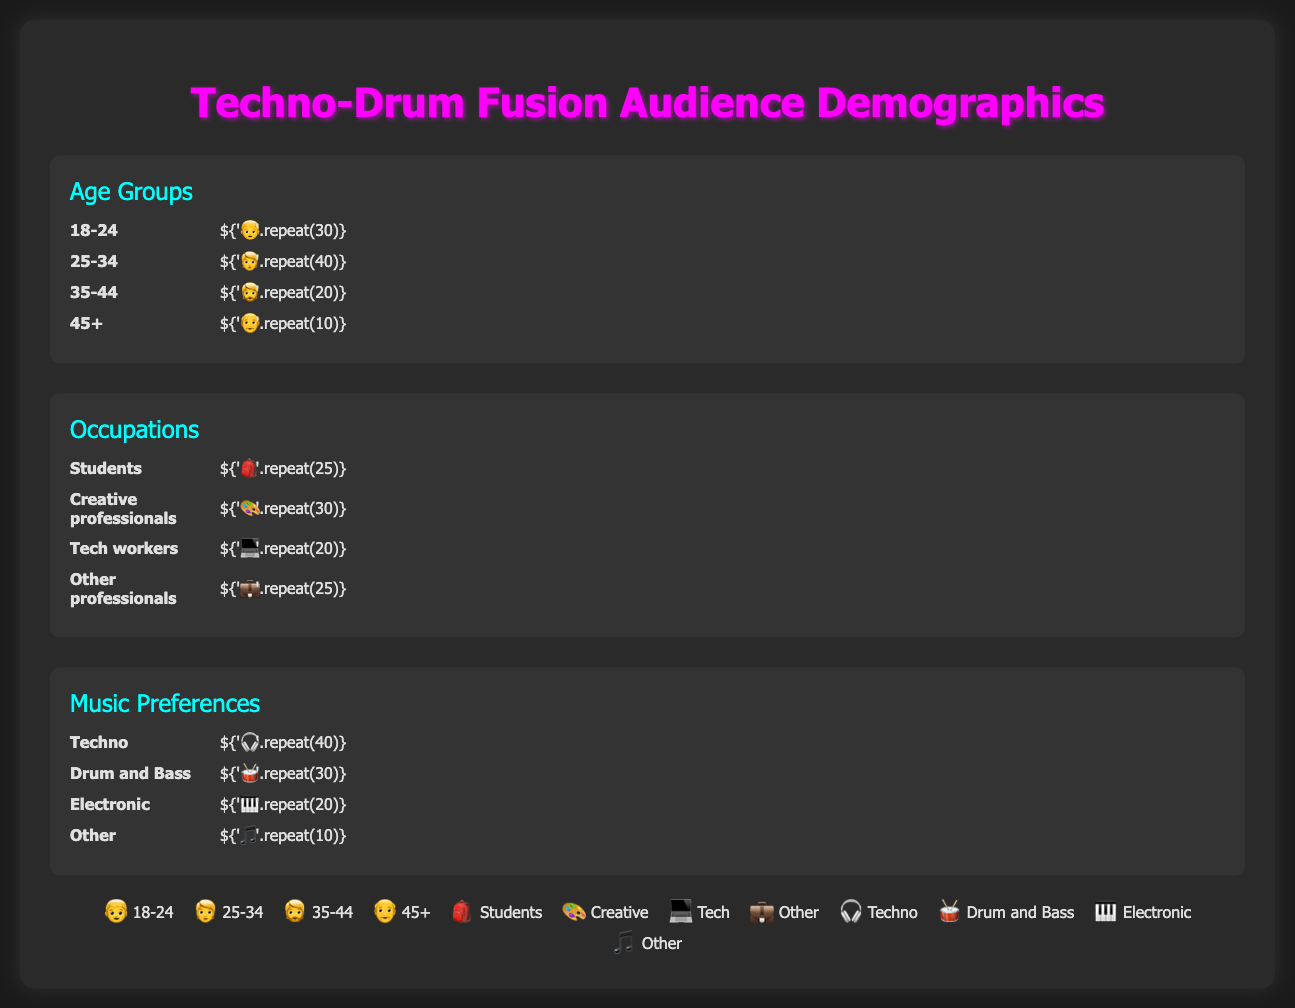Who represents the largest age group in the audience? From the Isotype Plot, the 25-34 age group has 40 icons, which is the highest compared to other age groups (each icon represents 10 attendees).
Answer: 25-34 How many more 18-24-year-olds are there compared to 35-44-year-olds? The 18-24 age group has 30 icons and the 35-44 age group has 20 icons. Subtracting the two gives 30 - 20 = 10 icons. Each icon represents 10 attendees, so the difference is 10 * 10 = 100 attendees.
Answer: 100 What fraction of the attendees are identified as "Other professionals"? The "Other professionals" group has 25 icons. Since there are 100 icons in total representing 1000 attendees, the fraction is 25/100 = 1/4.
Answer: 1/4 Which music genre is preferred by the least number of attendees? The genre "Other" has the least number of icons, totaling 10 icons. This translates to 100 attendees, which is fewer than any other genre presented.
Answer: Other Are there more tech workers or students in the audience? The plot shows 20 icons for "Tech workers" and 25 icons for "Students". This translates to 200 tech workers and 250 students. Since 250 is greater than 200, there are more students.
Answer: Students What is the total number of attendees who prefer either Techno or Drum and Bass genres? The Techno genre has 40 icons and the Drum and Bass genre has 30 icons. Combined, they add up to 40 + 30 = 70 icons. Each icon represents 10 attendees, so it totals 70 * 10 = 700 attendees.
Answer: 700 What is the difference in the number of attendees between the "Creative professionals" and "Other professionals"? "Creative professionals" have 30 icons and "Other professionals" have 25 icons. The difference is 30 - 25 = 5 icons. Given that each icon represents 10 attendees, the difference is 5 * 10 = 50 attendees.
Answer: 50 Which age group constitutes exactly 20% of the total audience? From the plot, we see the 35-44 age group has 20 icons. Since there are 100 icons in total, 20/100 = 0.20 or 20%.
Answer: 35-44 How many people in the audience identify as either "Tech workers" or "Students"? "Tech workers" have 20 icons and "Students" have 25 icons. Adding them gives 20 + 25 = 45 icons, and with each icon representing 10 attendees, the total number is 45 * 10 = 450.
Answer: 450 What is the sum of attendees in the 18-24 and 45+ age groups? The 18-24 age group has 30 icons and the 45+ age group has 10 icons. Adding these gives 30 + 10 = 40 icons. Since each icon represents 10 attendees, the total number is 40 * 10 = 400 attendees.
Answer: 400 